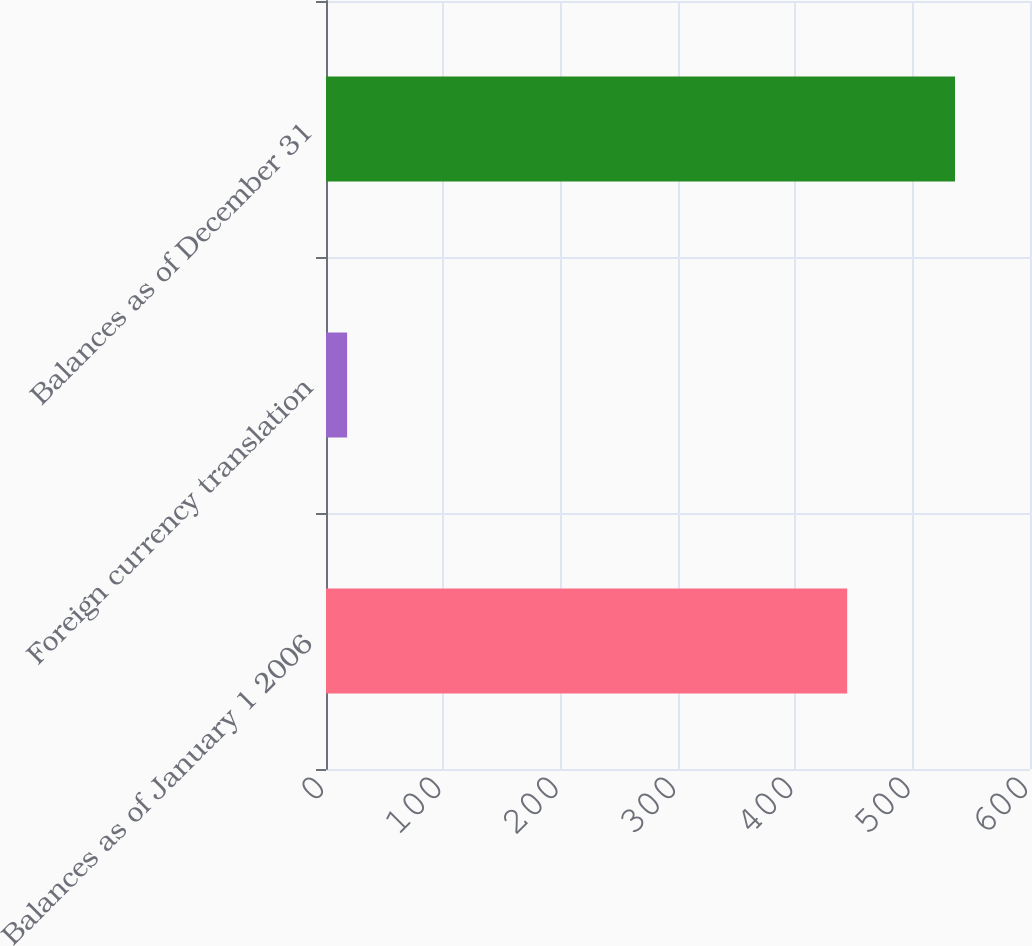<chart> <loc_0><loc_0><loc_500><loc_500><bar_chart><fcel>Balances as of January 1 2006<fcel>Foreign currency translation<fcel>Balances as of December 31<nl><fcel>444.2<fcel>18<fcel>536.08<nl></chart> 